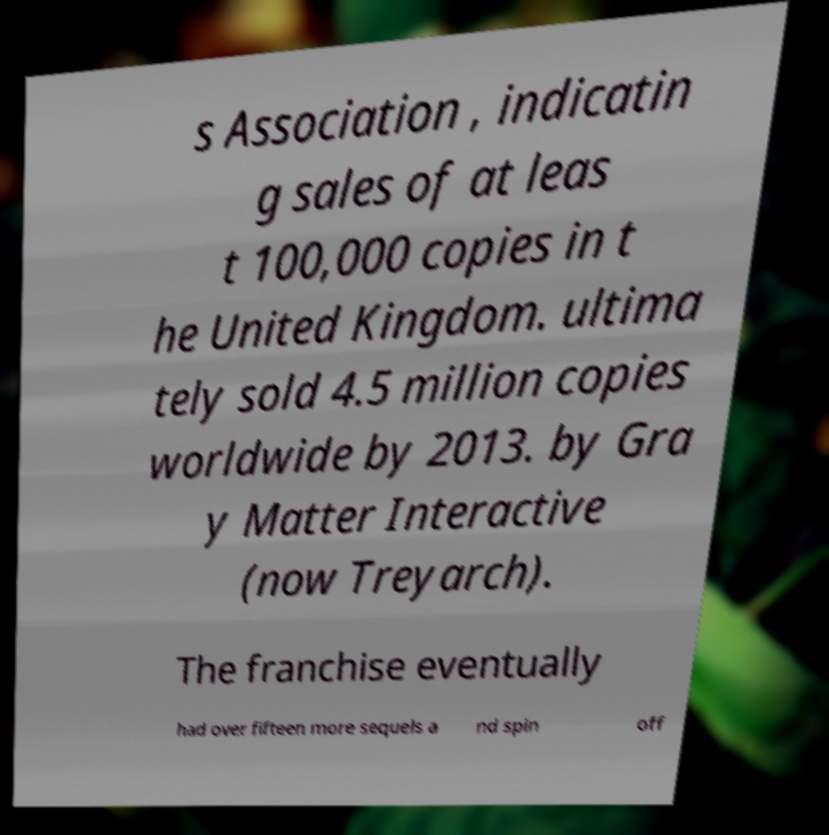Please identify and transcribe the text found in this image. s Association , indicatin g sales of at leas t 100,000 copies in t he United Kingdom. ultima tely sold 4.5 million copies worldwide by 2013. by Gra y Matter Interactive (now Treyarch). The franchise eventually had over fifteen more sequels a nd spin off 